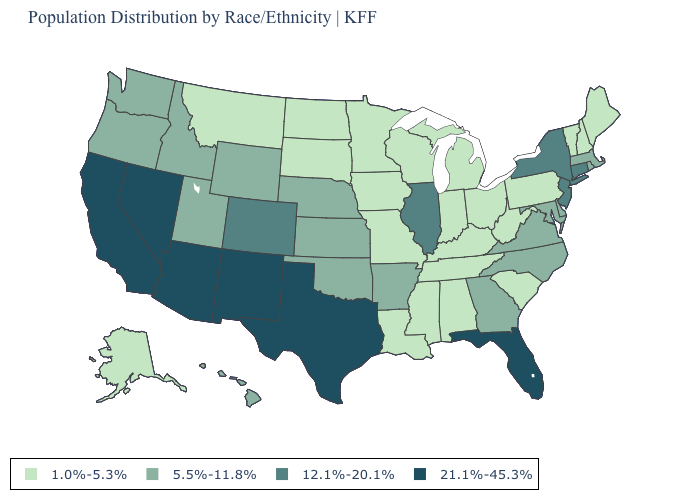Name the states that have a value in the range 21.1%-45.3%?
Concise answer only. Arizona, California, Florida, Nevada, New Mexico, Texas. Name the states that have a value in the range 5.5%-11.8%?
Short answer required. Arkansas, Delaware, Georgia, Hawaii, Idaho, Kansas, Maryland, Massachusetts, Nebraska, North Carolina, Oklahoma, Oregon, Rhode Island, Utah, Virginia, Washington, Wyoming. What is the value of Hawaii?
Keep it brief. 5.5%-11.8%. Does Idaho have a lower value than Connecticut?
Keep it brief. Yes. What is the lowest value in the South?
Be succinct. 1.0%-5.3%. What is the value of Louisiana?
Short answer required. 1.0%-5.3%. Does the map have missing data?
Write a very short answer. No. What is the highest value in states that border Oregon?
Keep it brief. 21.1%-45.3%. What is the value of Utah?
Concise answer only. 5.5%-11.8%. Does New York have the highest value in the Northeast?
Concise answer only. Yes. Does Mississippi have the lowest value in the USA?
Keep it brief. Yes. Is the legend a continuous bar?
Concise answer only. No. What is the highest value in the South ?
Quick response, please. 21.1%-45.3%. Does the map have missing data?
Quick response, please. No. Name the states that have a value in the range 12.1%-20.1%?
Be succinct. Colorado, Connecticut, Illinois, New Jersey, New York. 